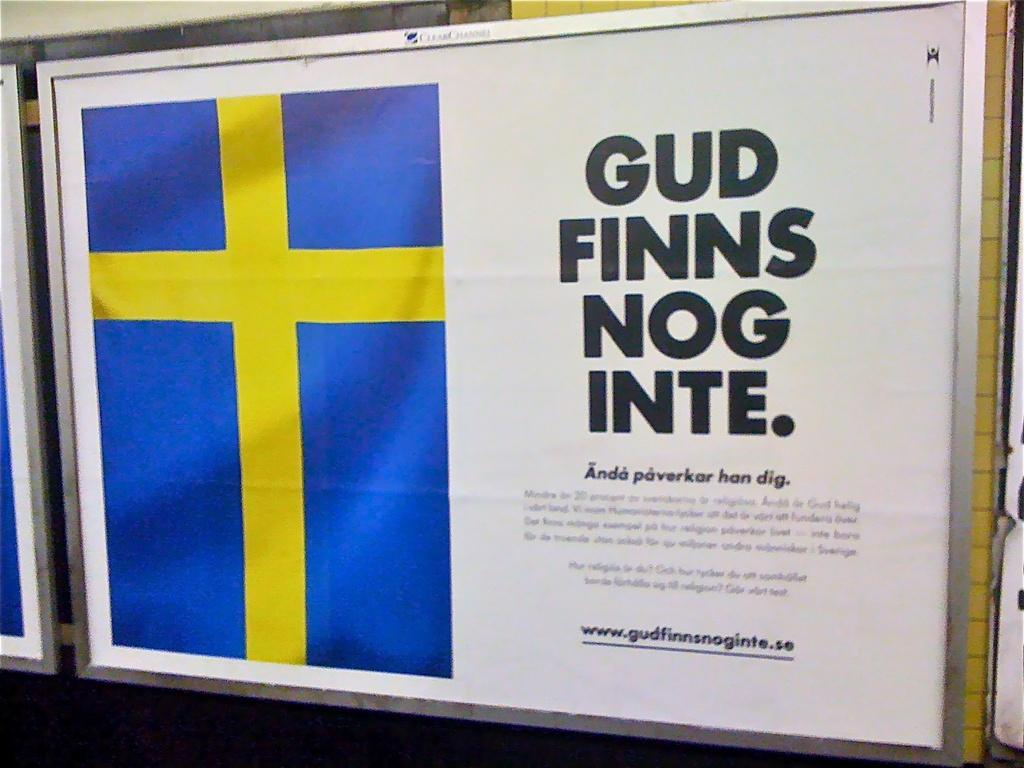<image>
Share a concise interpretation of the image provided. A sign shows the Swedish flag and says Gun Finns Nog Inte. 